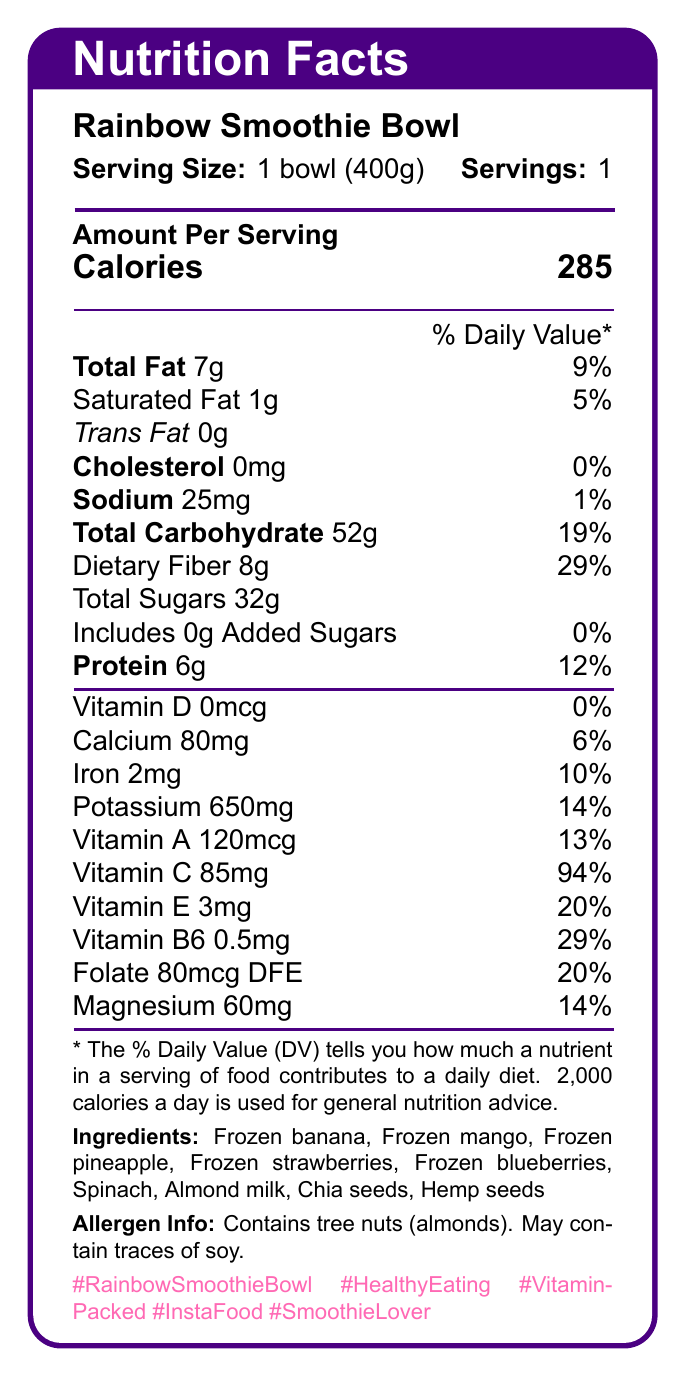What is the serving size for the Rainbow Smoothie Bowl? The serving size is directly mentioned in the document as 1 bowl (400g).
Answer: 1 bowl (400g) How many calories are in one serving of the Rainbow Smoothie Bowl? The calories in one serving are stated in the document as 285.
Answer: 285 What percentage of the daily value is the dietary fiber content? The dietary fiber content is listed as 8g, which is 29% of the daily value.
Answer: 29% Is there any cholesterol in the Rainbow Smoothie Bowl? The cholesterol amount is listed as 0mg with a 0% daily value, indicating no cholesterol.
Answer: No Which ingredient in the Rainbow Smoothie Bowl could be an allergen? The allergen information specifies that the product contains tree nuts (almonds).
Answer: Almonds Which of the following vitamins has the highest daily value percentage in the Rainbow Smoothie Bowl? A. Vitamin A B. Vitamin C C. Vitamin E D. Vitamin B6 Vitamin C has the highest daily value percentage at 94%.
Answer: B How many grams of protein does the Rainbow Smoothie Bowl contain? The document lists the protein content as 6g.
Answer: 6g Does the Rainbow Smoothie Bowl contain any added sugars? The total sugars are listed as 32g with added sugars at 0g.
Answer: No What is the sodium content of the Rainbow Smoothie Bowl in milligrams? The sodium content is directly noted in the document as 25mg.
Answer: 25mg What vitamins and minerals are found in the Rainbow Smoothie Bowl? Summarize the information. The document breaks down the specific vitamins and minerals along with their amounts in milligrams or micrograms and their corresponding daily values.
Answer: Vitamins and minerals include Vitamin D (0mcg), Calcium (80mg), Iron (2mg), Potassium (650mg), Vitamin A (120mcg), Vitamin C (85mg), Vitamin E (3mg), Vitamin B6 (0.5mg), Folate (80mcg DFE), and Magnesium (60mg). What are the main ingredients in the Rainbow Smoothie Bowl? The list of main ingredients is provided in the document.
Answer: Frozen banana, Frozen mango, Frozen pineapple, Frozen strawberries, Frozen blueberries, Spinach, Almond milk, Chia seeds, Hemp seeds What hashtags are associated with the Rainbow Smoothie Bowl on social media? The hashtags are directly listed at the end of the document.
Answer: #RainbowSmoothieBowl, #HealthyEating, #VitaminPacked, #InstaFood, #SmoothieLover How much vitamin B6 does the Rainbow Smoothie Bowl contain in milligrams? The vitamin B6 content is noted as 0.5mg.
Answer: 0.5mg Does the Rainbow Smoothie Bowl contain any trans fat? Trans fat content is listed as 0g, indicating there is no trans fat.
Answer: No What is the allergen warning mentioned in the document? A. Contains peanuts B. Contains dairy C. Contains tree nuts (almonds) D. Contains gluten The allergen warning specifies that the product contains tree nuts (almonds).
Answer: C What is the social caption for the Rainbow Smoothie Bowl? The social caption provided in the document emphasizes the appeal and nutritional value of the Rainbow Smoothie Bowl and encourages interaction on social media.
Answer: Start your day with a burst of colors and nutrients! 🌈 This Rainbow Smoothie Bowl is not just Instagram-worthy, but also packed with vitamins and minerals to keep you energized. Double tap if you'd love to try this! 💕 What's your favorite smoothie bowl combo? Share in the comments below! 👇 How much folate is in the Rainbow Smoothie Bowl? The folate content is given as 80mcg DFE in the document.
Answer: 80mcg DFE What type of milk is used in the Rainbow Smoothie Bowl? The ingredients list mentions almond milk as one of the components.
Answer: Almond milk What is the main idea of the document? The document provides comprehensive nutritional information about the Rainbow Smoothie Bowl, including its ingredients and allergen warnings, while also promoting its social media presence.
Answer: The document details the nutrition facts, ingredients, allergen information, and social media aspect of the Rainbow Smoothie Bowl, highlighting its caloric, vitamin, and mineral content. What are the preparation instructions for the Rainbow Smoothie Bowl? The document contains nutrition facts and ingredients but does not include any preparation instructions.
Answer: Not enough information 